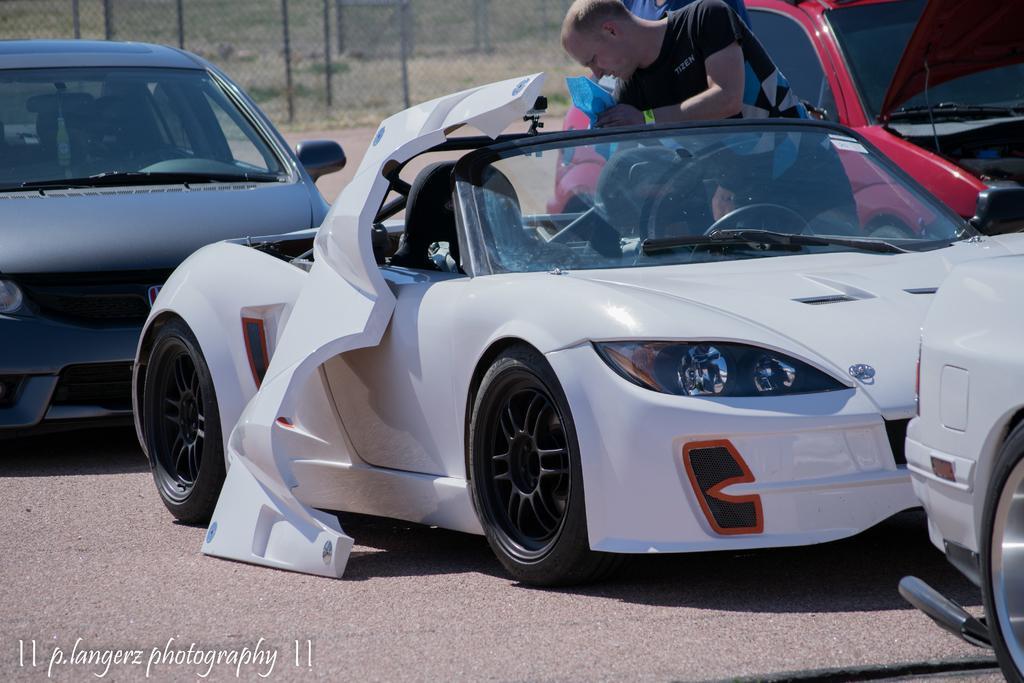Please provide a concise description of this image. In this image we can see the vehicles. We can also see two persons. In the background we can see the fence and at the bottom we can see the road. In the bottom left corner we can see the text. 